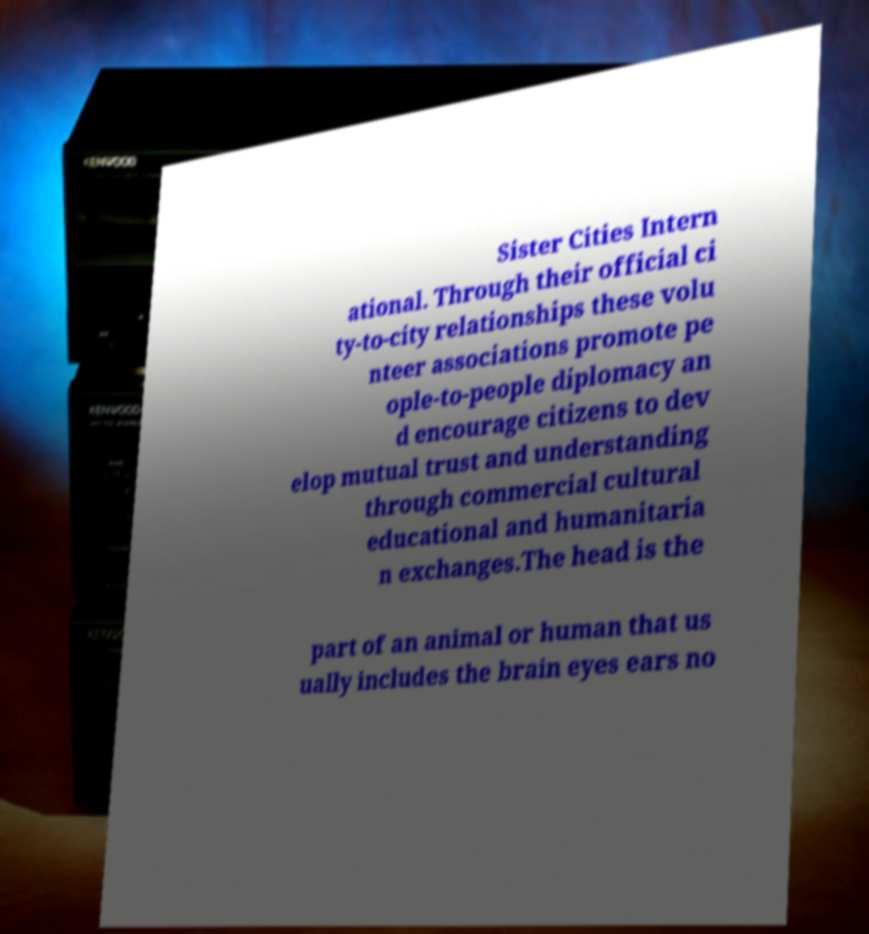There's text embedded in this image that I need extracted. Can you transcribe it verbatim? Sister Cities Intern ational. Through their official ci ty-to-city relationships these volu nteer associations promote pe ople-to-people diplomacy an d encourage citizens to dev elop mutual trust and understanding through commercial cultural educational and humanitaria n exchanges.The head is the part of an animal or human that us ually includes the brain eyes ears no 